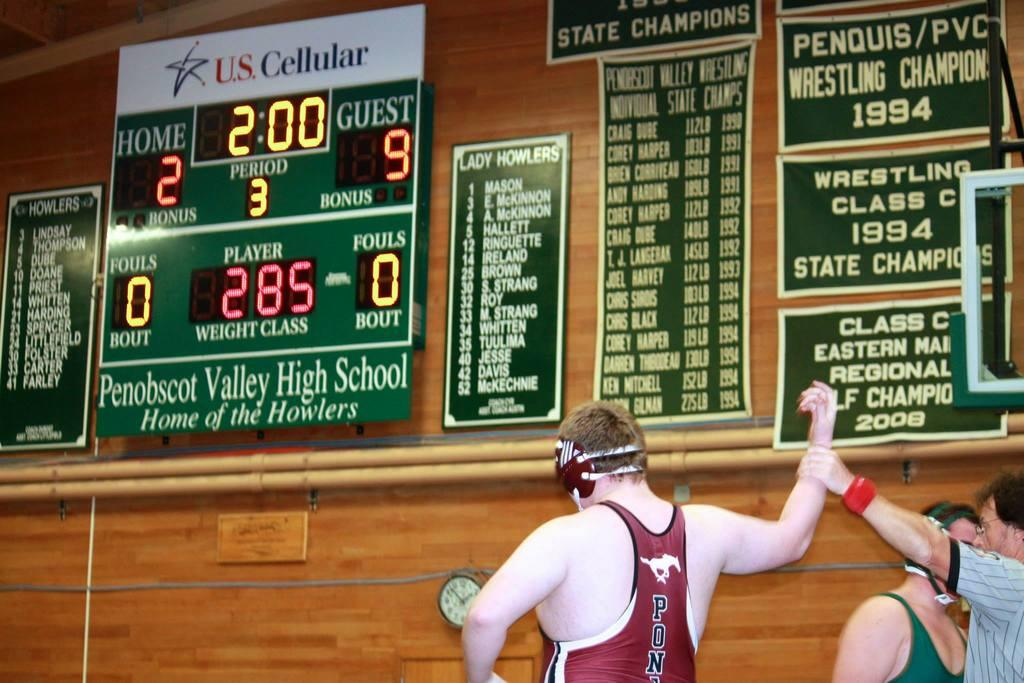<image>
Present a compact description of the photo's key features. A referee is holding the arm of a wrestler in the air under a scorecard that says Penobscot Valley High School. 